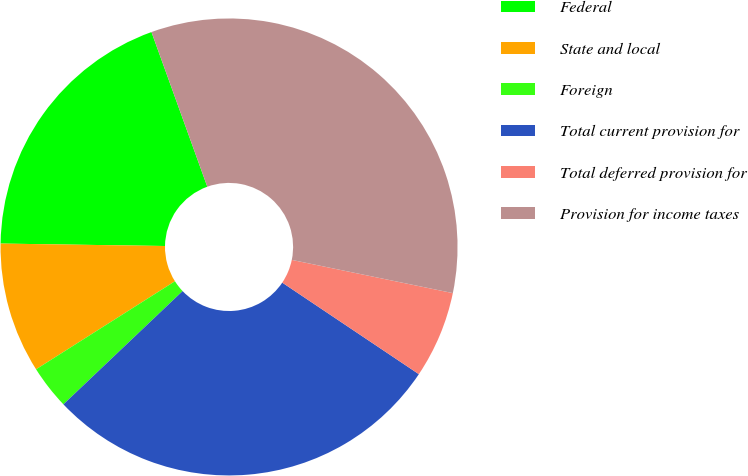Convert chart to OTSL. <chart><loc_0><loc_0><loc_500><loc_500><pie_chart><fcel>Federal<fcel>State and local<fcel>Foreign<fcel>Total current provision for<fcel>Total deferred provision for<fcel>Provision for income taxes<nl><fcel>19.25%<fcel>9.23%<fcel>3.1%<fcel>28.51%<fcel>6.16%<fcel>33.75%<nl></chart> 